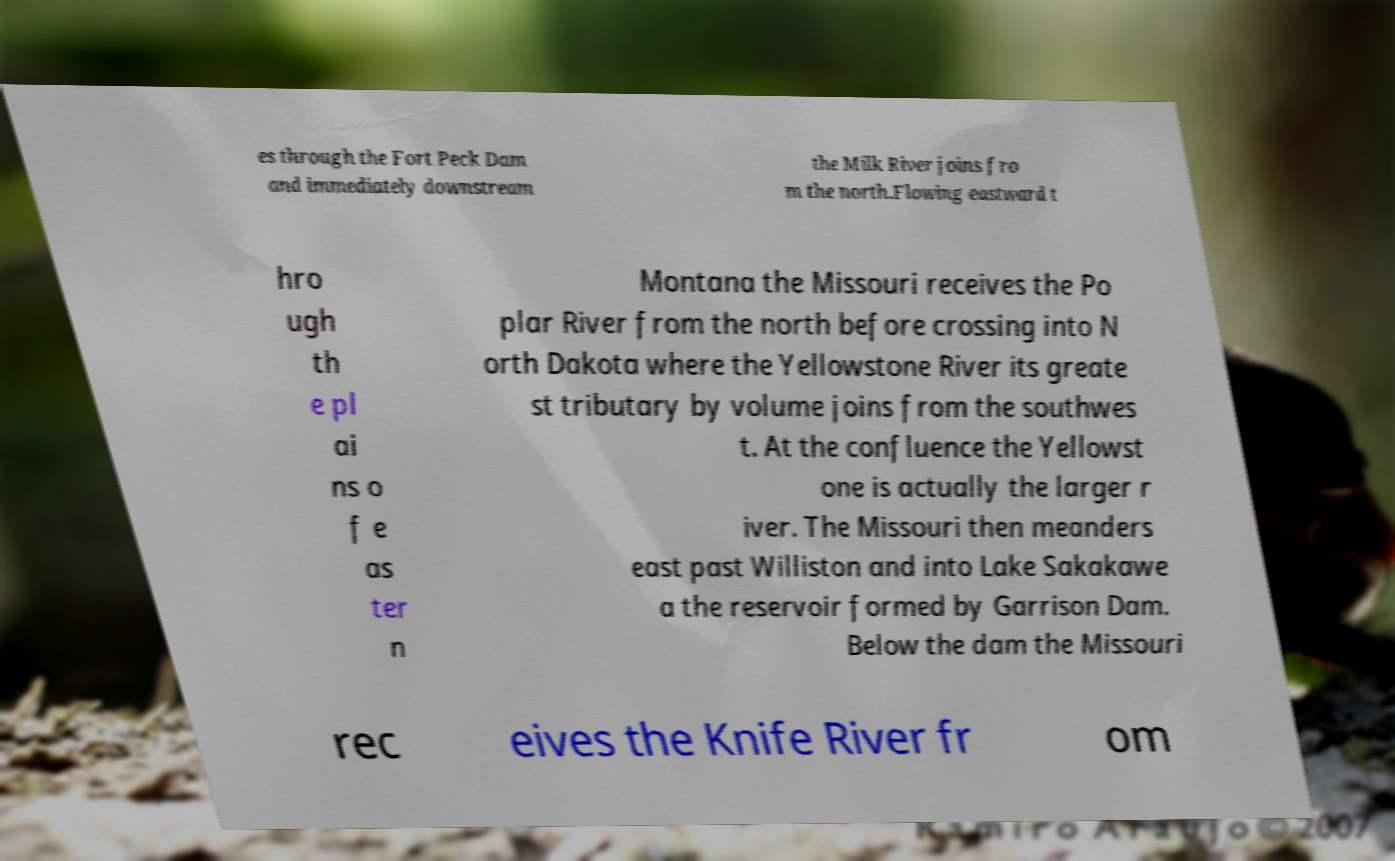What messages or text are displayed in this image? I need them in a readable, typed format. es through the Fort Peck Dam and immediately downstream the Milk River joins fro m the north.Flowing eastward t hro ugh th e pl ai ns o f e as ter n Montana the Missouri receives the Po plar River from the north before crossing into N orth Dakota where the Yellowstone River its greate st tributary by volume joins from the southwes t. At the confluence the Yellowst one is actually the larger r iver. The Missouri then meanders east past Williston and into Lake Sakakawe a the reservoir formed by Garrison Dam. Below the dam the Missouri rec eives the Knife River fr om 